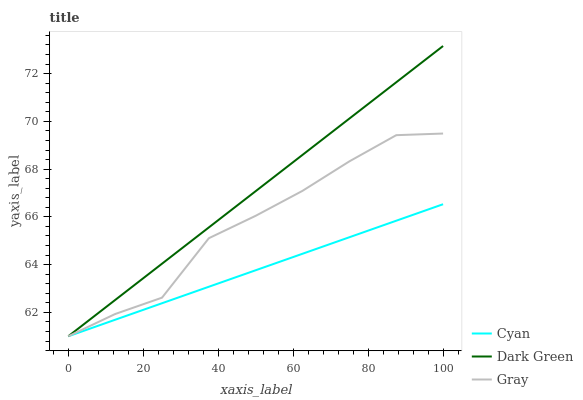Does Cyan have the minimum area under the curve?
Answer yes or no. Yes. Does Dark Green have the maximum area under the curve?
Answer yes or no. Yes. Does Gray have the minimum area under the curve?
Answer yes or no. No. Does Gray have the maximum area under the curve?
Answer yes or no. No. Is Dark Green the smoothest?
Answer yes or no. Yes. Is Gray the roughest?
Answer yes or no. Yes. Is Gray the smoothest?
Answer yes or no. No. Is Dark Green the roughest?
Answer yes or no. No. Does Cyan have the lowest value?
Answer yes or no. Yes. Does Dark Green have the highest value?
Answer yes or no. Yes. Does Gray have the highest value?
Answer yes or no. No. Does Cyan intersect Gray?
Answer yes or no. Yes. Is Cyan less than Gray?
Answer yes or no. No. Is Cyan greater than Gray?
Answer yes or no. No. 